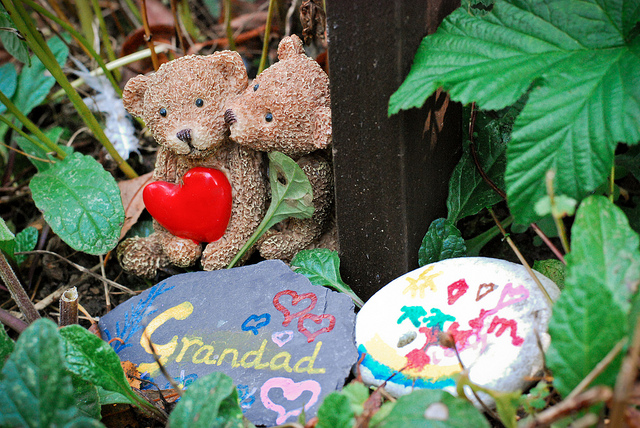Identify the text contained in this image. Grandad R m 